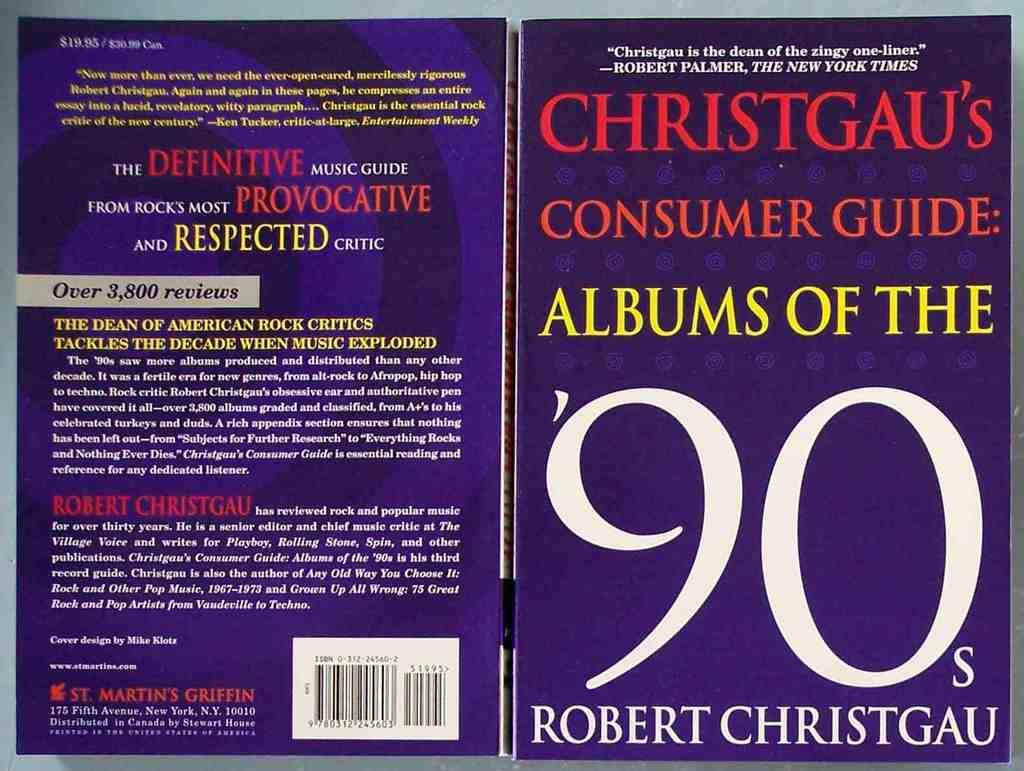<image>
Provide a brief description of the given image. The book is about Albums from the 1990's 